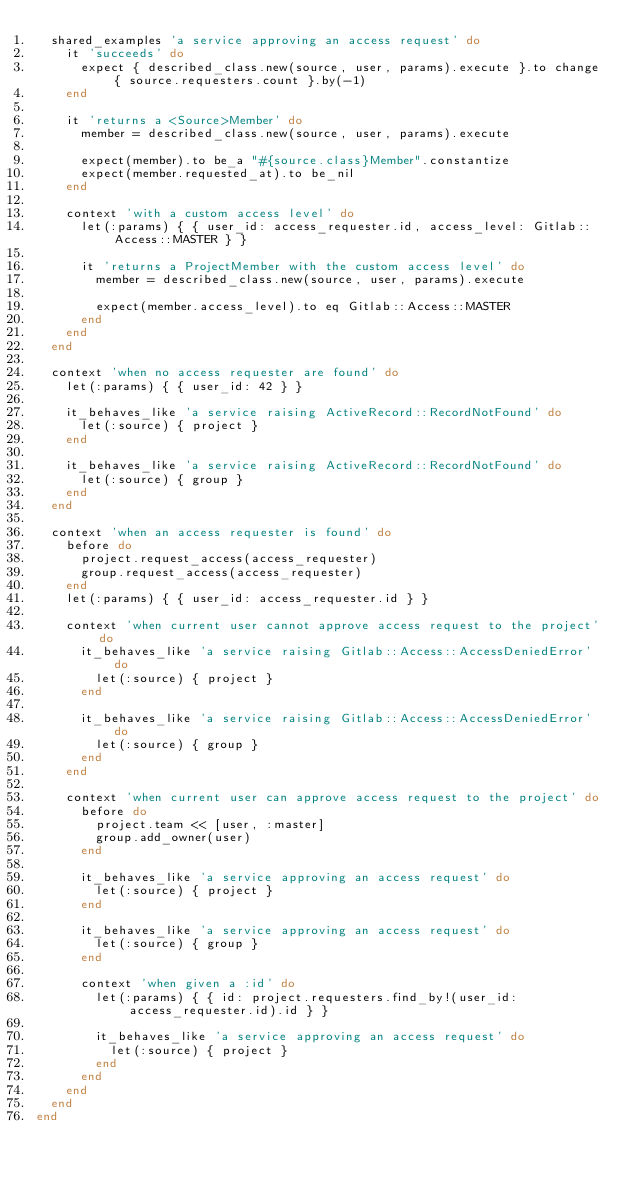<code> <loc_0><loc_0><loc_500><loc_500><_Ruby_>  shared_examples 'a service approving an access request' do
    it 'succeeds' do
      expect { described_class.new(source, user, params).execute }.to change { source.requesters.count }.by(-1)
    end

    it 'returns a <Source>Member' do
      member = described_class.new(source, user, params).execute

      expect(member).to be_a "#{source.class}Member".constantize
      expect(member.requested_at).to be_nil
    end

    context 'with a custom access level' do
      let(:params) { { user_id: access_requester.id, access_level: Gitlab::Access::MASTER } }

      it 'returns a ProjectMember with the custom access level' do
        member = described_class.new(source, user, params).execute

        expect(member.access_level).to eq Gitlab::Access::MASTER
      end
    end
  end

  context 'when no access requester are found' do
    let(:params) { { user_id: 42 } }

    it_behaves_like 'a service raising ActiveRecord::RecordNotFound' do
      let(:source) { project }
    end

    it_behaves_like 'a service raising ActiveRecord::RecordNotFound' do
      let(:source) { group }
    end
  end

  context 'when an access requester is found' do
    before do
      project.request_access(access_requester)
      group.request_access(access_requester)
    end
    let(:params) { { user_id: access_requester.id } }

    context 'when current user cannot approve access request to the project' do
      it_behaves_like 'a service raising Gitlab::Access::AccessDeniedError' do
        let(:source) { project }
      end

      it_behaves_like 'a service raising Gitlab::Access::AccessDeniedError' do
        let(:source) { group }
      end
    end

    context 'when current user can approve access request to the project' do
      before do
        project.team << [user, :master]
        group.add_owner(user)
      end

      it_behaves_like 'a service approving an access request' do
        let(:source) { project }
      end

      it_behaves_like 'a service approving an access request' do
        let(:source) { group }
      end

      context 'when given a :id' do
        let(:params) { { id: project.requesters.find_by!(user_id: access_requester.id).id } }

        it_behaves_like 'a service approving an access request' do
          let(:source) { project }
        end
      end
    end
  end
end
</code> 